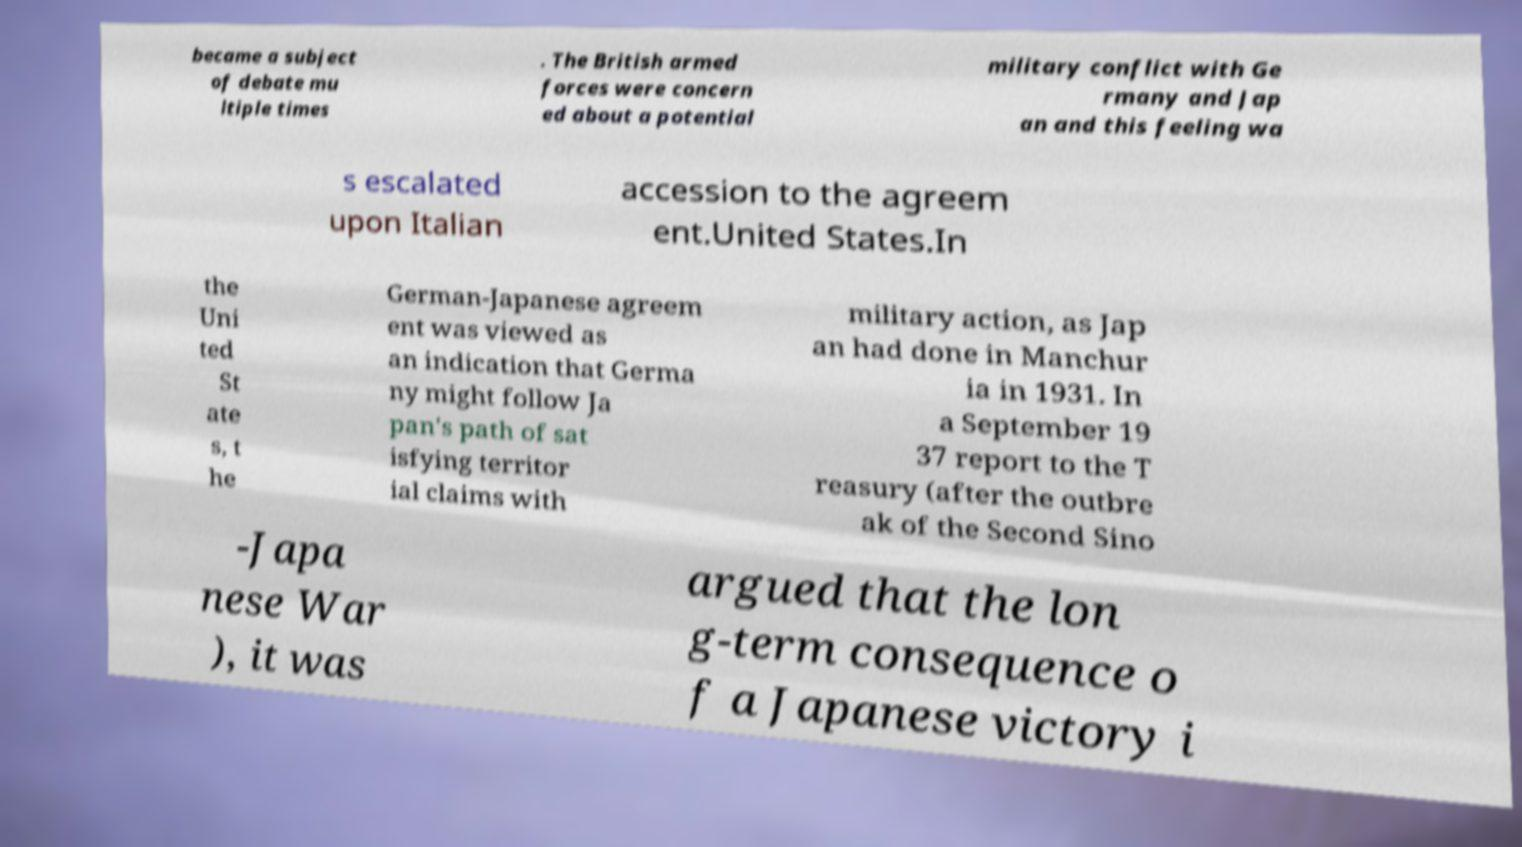I need the written content from this picture converted into text. Can you do that? became a subject of debate mu ltiple times . The British armed forces were concern ed about a potential military conflict with Ge rmany and Jap an and this feeling wa s escalated upon Italian accession to the agreem ent.United States.In the Uni ted St ate s, t he German-Japanese agreem ent was viewed as an indication that Germa ny might follow Ja pan's path of sat isfying territor ial claims with military action, as Jap an had done in Manchur ia in 1931. In a September 19 37 report to the T reasury (after the outbre ak of the Second Sino -Japa nese War ), it was argued that the lon g-term consequence o f a Japanese victory i 